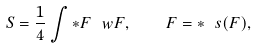<formula> <loc_0><loc_0><loc_500><loc_500>S = \frac { 1 } { 4 } \int \ast F \ w F , \quad F = \ast \ s ( F ) ,</formula> 